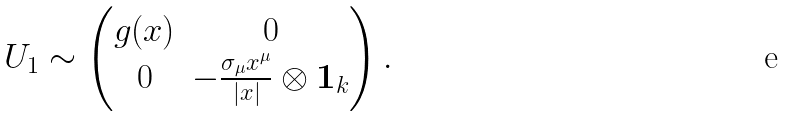<formula> <loc_0><loc_0><loc_500><loc_500>U _ { 1 } \sim \left ( \begin{matrix} g ( x ) & 0 \\ 0 & - \frac { \sigma _ { \mu } x ^ { \mu } } { | x | } \otimes { \mathbf 1 } _ { k } \end{matrix} \right ) .</formula> 